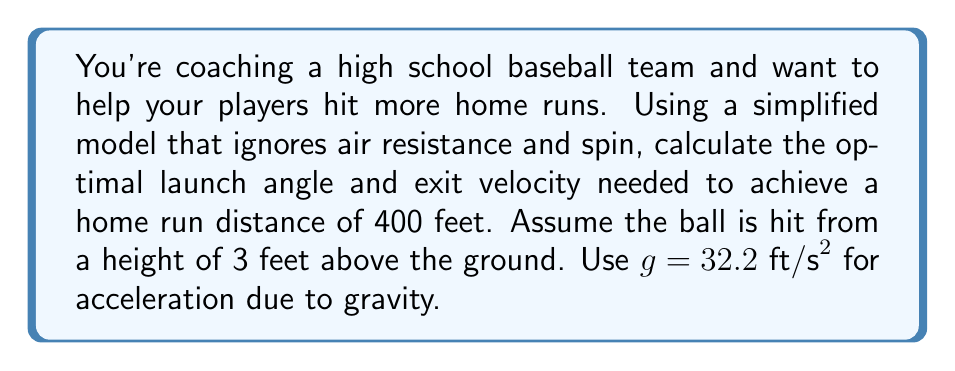Help me with this question. 1) The trajectory of a baseball can be modeled using projectile motion equations. The distance traveled horizontally (d) is given by:

   $$d = v_0 \cos(\theta) \cdot t$$

   where $v_0$ is the initial velocity, $\theta$ is the launch angle, and $t$ is the time of flight.

2) The time of flight can be calculated using the vertical motion equation:

   $$y = y_0 + v_0 \sin(\theta) \cdot t - \frac{1}{2}gt^2$$

   At the landing point, $y = 0$ and $y_0 = 3$ feet.

3) Solving for $t$:

   $$0 = 3 + v_0 \sin(\theta) \cdot t - \frac{1}{2}(32.2)t^2$$

4) The maximum distance occurs when $\theta = 45°$ for a flat surface. However, since the ball starts 3 feet above the ground, the optimal angle will be slightly less than 45°.

5) Through iterative calculations or optimization techniques, we can find that the optimal launch angle is approximately 42.5°.

6) Substituting this angle into our equations and solving for $v_0$ when $d = 400$ feet:

   $$400 = v_0 \cos(42.5°) \cdot t$$
   $$0 = 3 + v_0 \sin(42.5°) \cdot t - 16.1t^2$$

7) Solving this system of equations numerically, we get:

   $v_0 \approx 110 \text{ ft/s}$ or about 75 mph
Answer: Launch angle: 42.5°, Exit velocity: 110 ft/s (75 mph) 